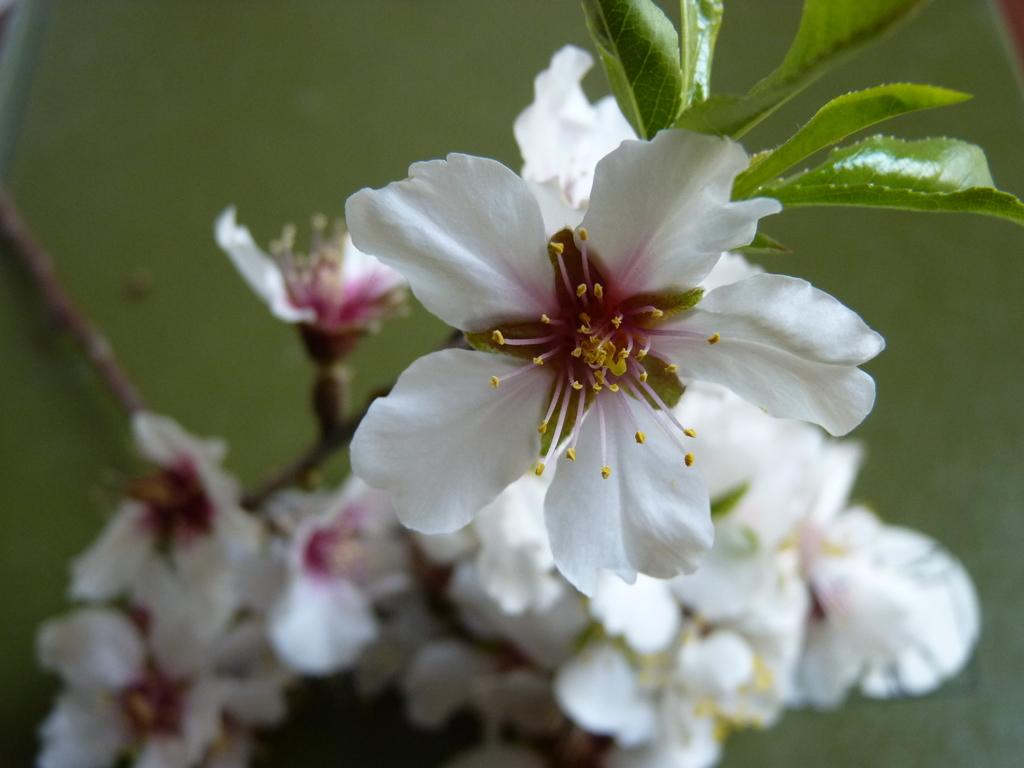What type of flowers can be seen in the image? There are white color flowers in the image. What else is present in the image besides the flowers? There are leaves in the image. Can you describe the background of the image? The background of the image is blurry. What type of ship can be seen in the front of the image? There is no ship present in the image; it features white color flowers and leaves. What type of calculator is visible on the leaves in the image? There is no calculator present on the leaves in the image. 